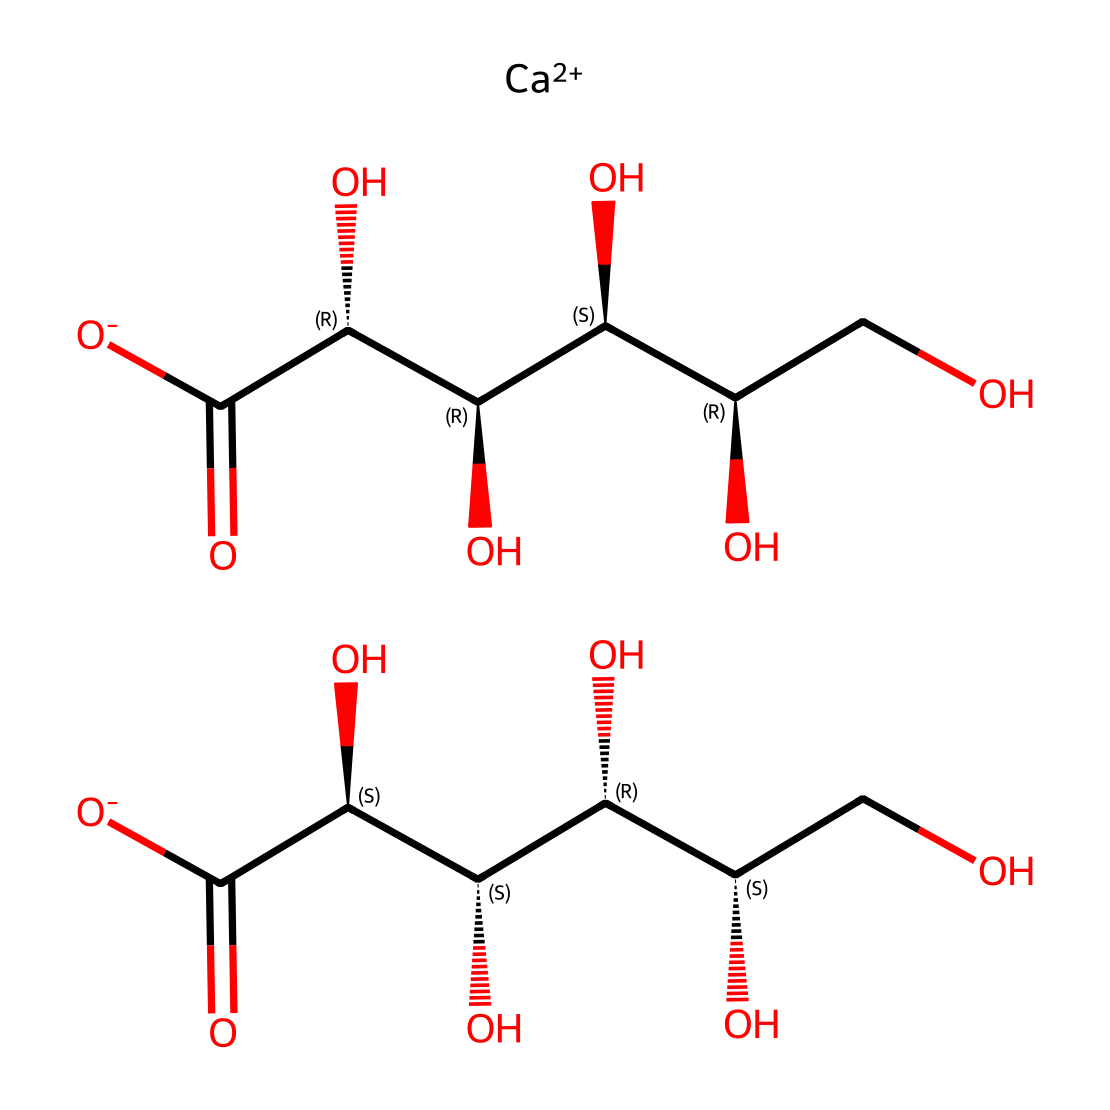What is the molecular formula of calcium gluconate? By analyzing the structure and taking into account the number of each type of atom observed in the SMILES representation, we can determine the molecular formula. Calcium, represented by [Ca++], indicates one calcium atom. The presence of multiple -OH groups and carboxyl groups (C(=O)[O-]) indicates multiple carbon and oxygen atoms. Summing these up results in a molecular formula of C12H22CaO14.
Answer: C12H22CaO14 How many hydroxyl groups are in the structure? In the chemical structure, hydroxyl groups (–OH) are clearly indicated by the presence of the oxygen atom bonded to hydrogen within the molecule. Counting the occurrences, we find five hydroxyl groups present in the structure.
Answer: five What type of electrolyte is calcium gluconate classified as? Calcium gluconate is classified as a mineral electrolyte because it contains calcium ions which are essential for various bodily functions, particularly in bone health. This classification is based on its nature and role in physiologically important processes.
Answer: mineral How many stereocenters are present in calcium gluconate? In analyzing the structure for stereochemistry, stereocenters are determined by carbon atoms that have four distinct substituents. Upon reviewing the SMILES representation, we identify four carbons with stereochemistry indications, which reveals that there are four stereocenters in total.
Answer: four What is the significance of calcium in this compound? Calcium plays a critical role as a vital mineral for bone health, contributing to bone density and structural integrity. It is essential to human physiology as an electrolyte, influencing nerve function and muscle contraction. The presence of calcium makes this compound an important dietary supplement.
Answer: bone health 